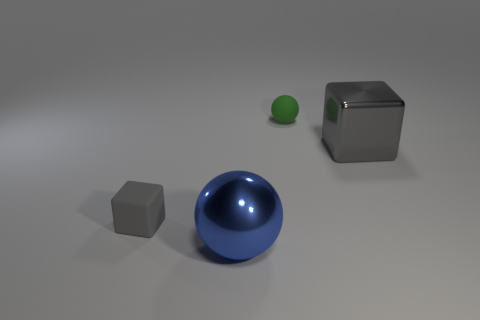Add 4 small gray blocks. How many objects exist? 8 Subtract 0 brown spheres. How many objects are left? 4 Subtract all large brown blocks. Subtract all blue spheres. How many objects are left? 3 Add 3 big balls. How many big balls are left? 4 Add 2 blue metallic cubes. How many blue metallic cubes exist? 2 